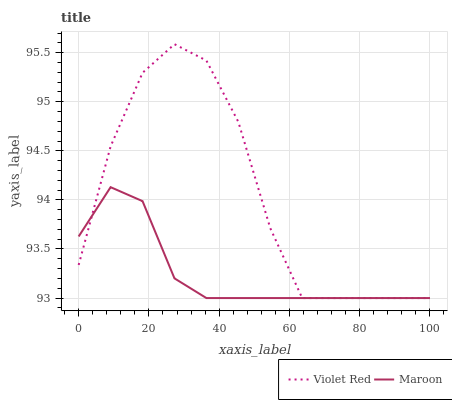Does Maroon have the maximum area under the curve?
Answer yes or no. No. Is Maroon the roughest?
Answer yes or no. No. Does Maroon have the highest value?
Answer yes or no. No. 